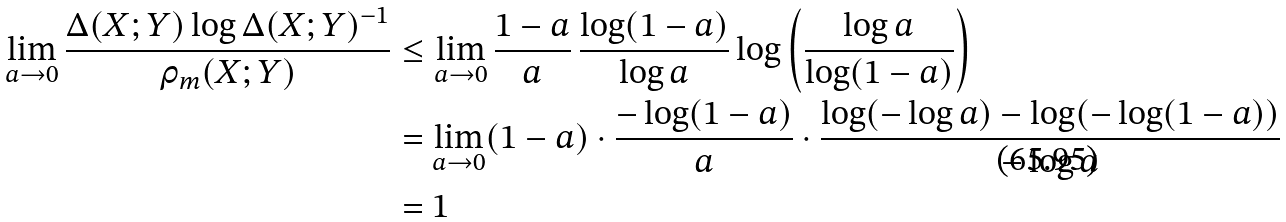<formula> <loc_0><loc_0><loc_500><loc_500>\lim _ { a \to 0 } \frac { \Delta ( X ; Y ) \log \Delta ( X ; Y ) ^ { - 1 } } { \rho _ { m } ( X ; Y ) } & \leq \lim _ { a \to 0 } \frac { 1 - a } { a } \, \frac { \log ( 1 - a ) } { \log a } \log \left ( \frac { \log a } { \log ( 1 - a ) } \right ) \\ & = \lim _ { a \to 0 } ( 1 - a ) \cdot \frac { - \log ( 1 - a ) } { a } \cdot \frac { \log ( - \log a ) - \log ( - \log ( 1 - a ) ) } { - \log a } \\ & = 1</formula> 